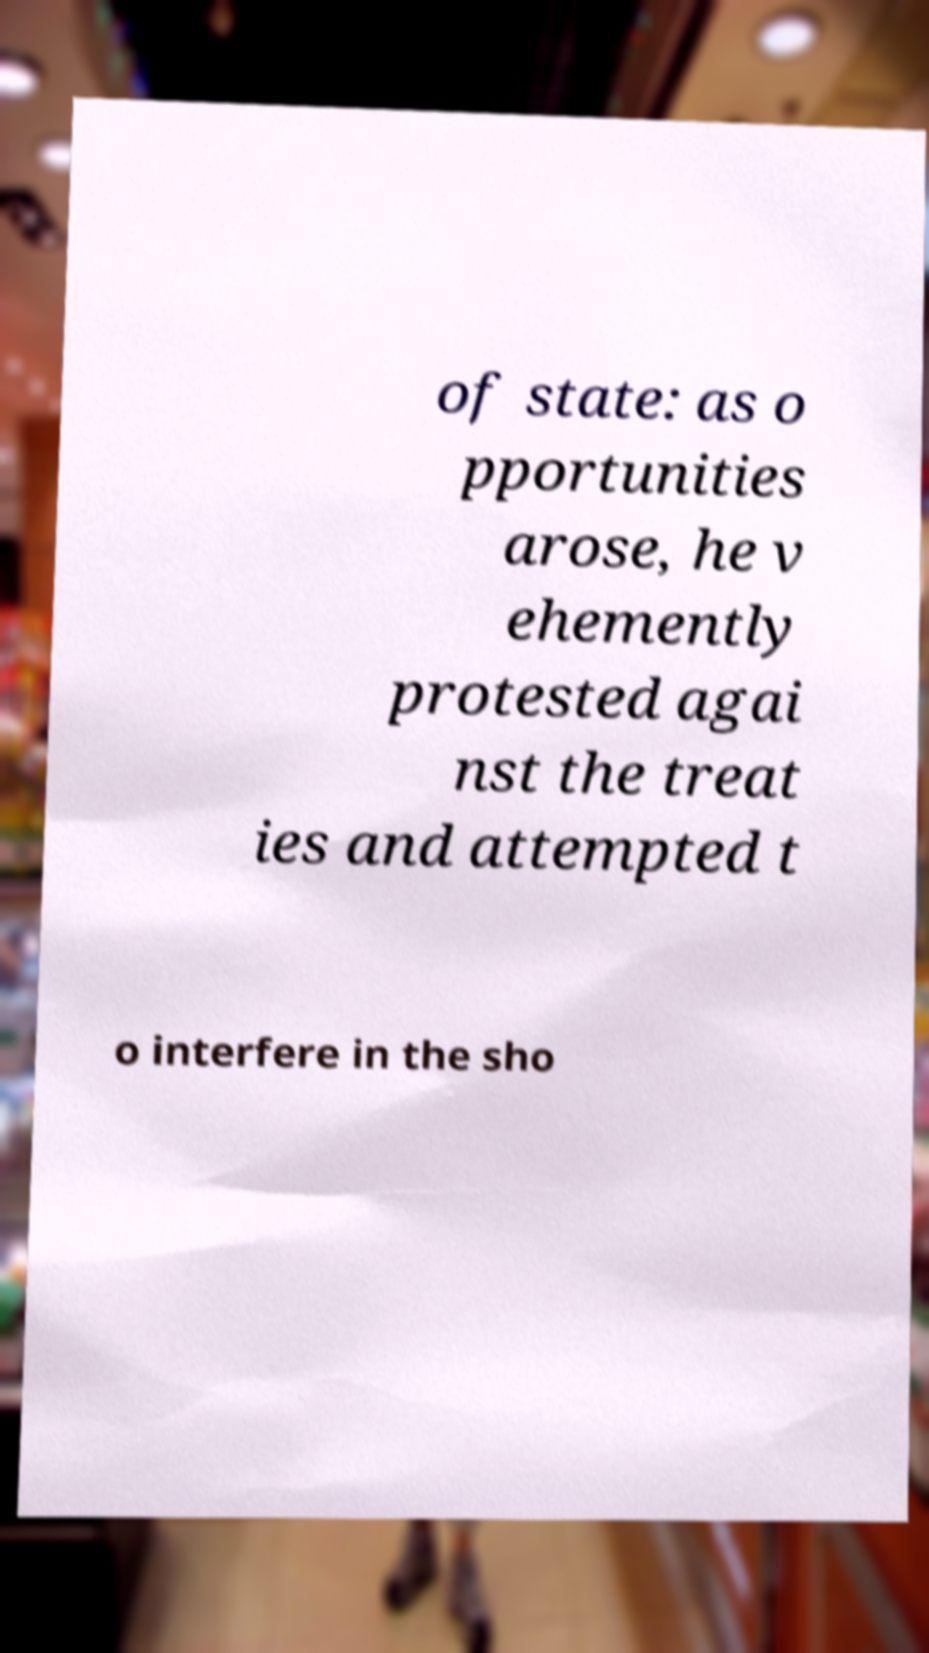What messages or text are displayed in this image? I need them in a readable, typed format. of state: as o pportunities arose, he v ehemently protested agai nst the treat ies and attempted t o interfere in the sho 